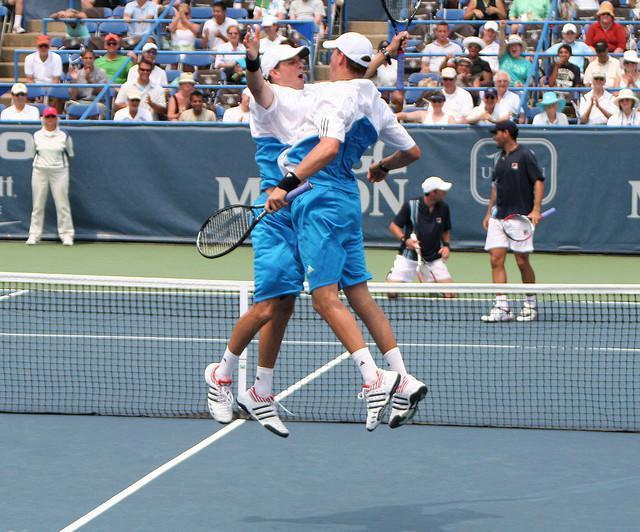How many people are visible?
Give a very brief answer. 6. 